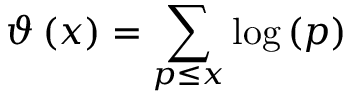<formula> <loc_0><loc_0><loc_500><loc_500>\vartheta \left ( x \right ) = \sum _ { p \leq x } { \log \left ( p \right ) }</formula> 